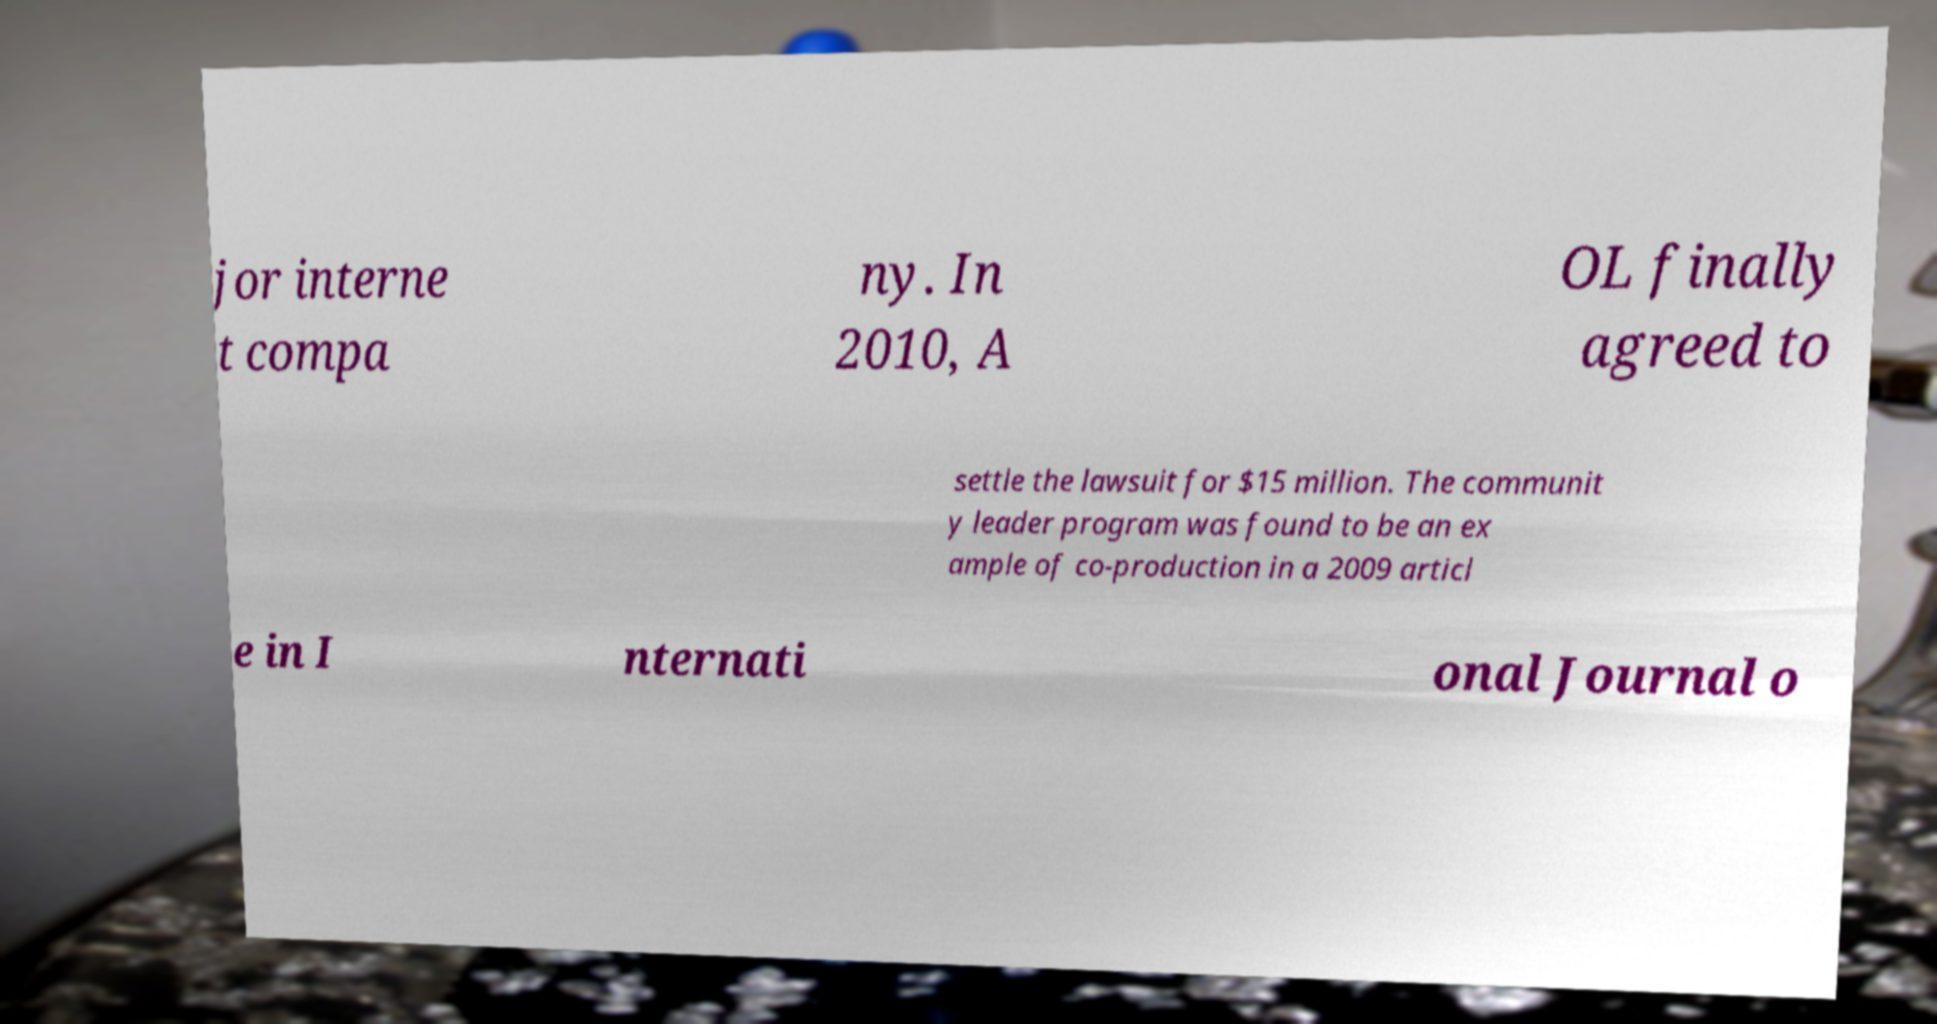There's text embedded in this image that I need extracted. Can you transcribe it verbatim? jor interne t compa ny. In 2010, A OL finally agreed to settle the lawsuit for $15 million. The communit y leader program was found to be an ex ample of co-production in a 2009 articl e in I nternati onal Journal o 